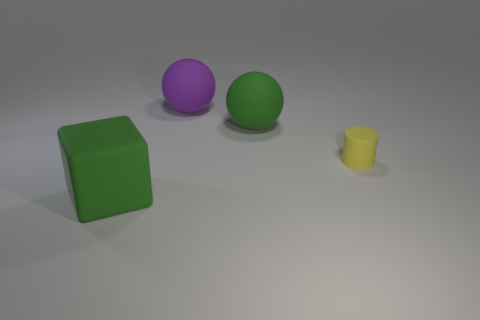What number of big spheres are the same color as the large cube?
Make the answer very short. 1. What number of other objects are there of the same shape as the small yellow matte thing?
Your response must be concise. 0. There is a yellow thing; does it have the same shape as the large green thing that is in front of the tiny yellow matte cylinder?
Provide a succinct answer. No. What number of tiny objects are either purple spheres or yellow matte cylinders?
Your answer should be very brief. 1. Is the number of purple things that are in front of the tiny yellow object less than the number of rubber cubes that are to the left of the big purple ball?
Keep it short and to the point. Yes. What number of things are either small purple metallic cylinders or large objects?
Keep it short and to the point. 3. What number of rubber things are to the right of the purple object?
Give a very brief answer. 2. Is the rubber cube the same color as the rubber cylinder?
Your answer should be compact. No. There is a purple object that is the same material as the cylinder; what shape is it?
Your answer should be compact. Sphere. There is a big green rubber thing that is behind the rubber cylinder; does it have the same shape as the yellow rubber thing?
Make the answer very short. No. 